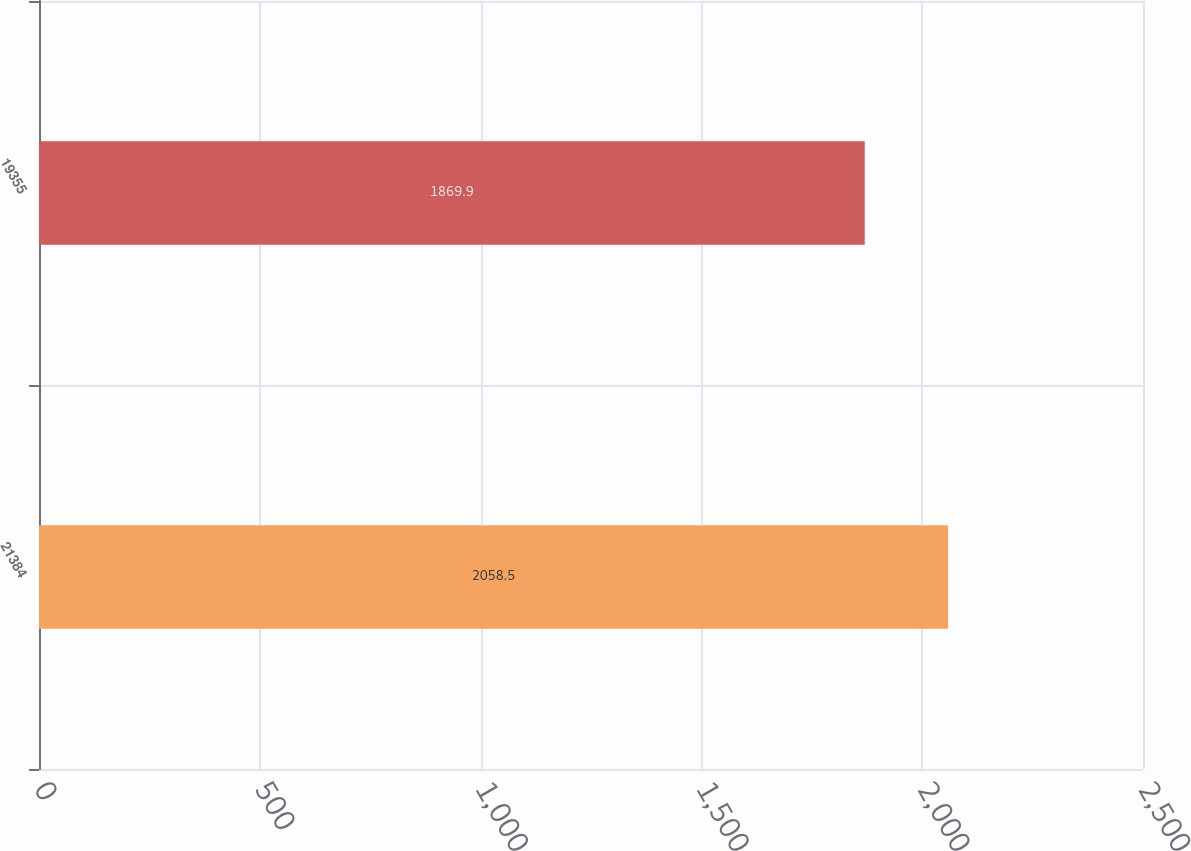Convert chart. <chart><loc_0><loc_0><loc_500><loc_500><bar_chart><fcel>21384<fcel>19355<nl><fcel>2058.5<fcel>1869.9<nl></chart> 